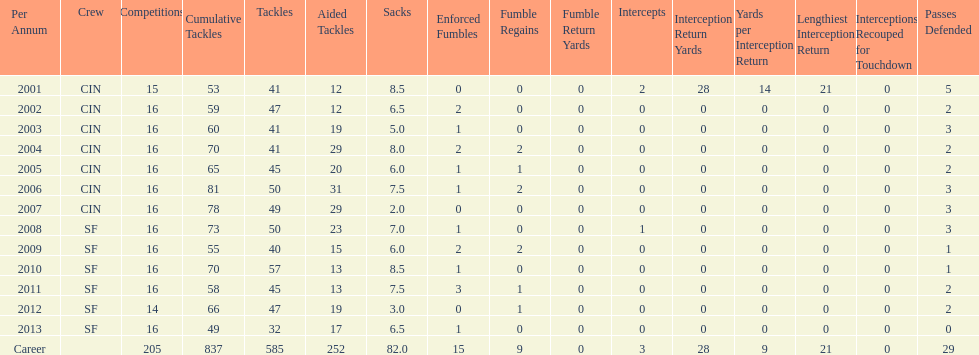How many years did he play in less than 16 games? 2. 